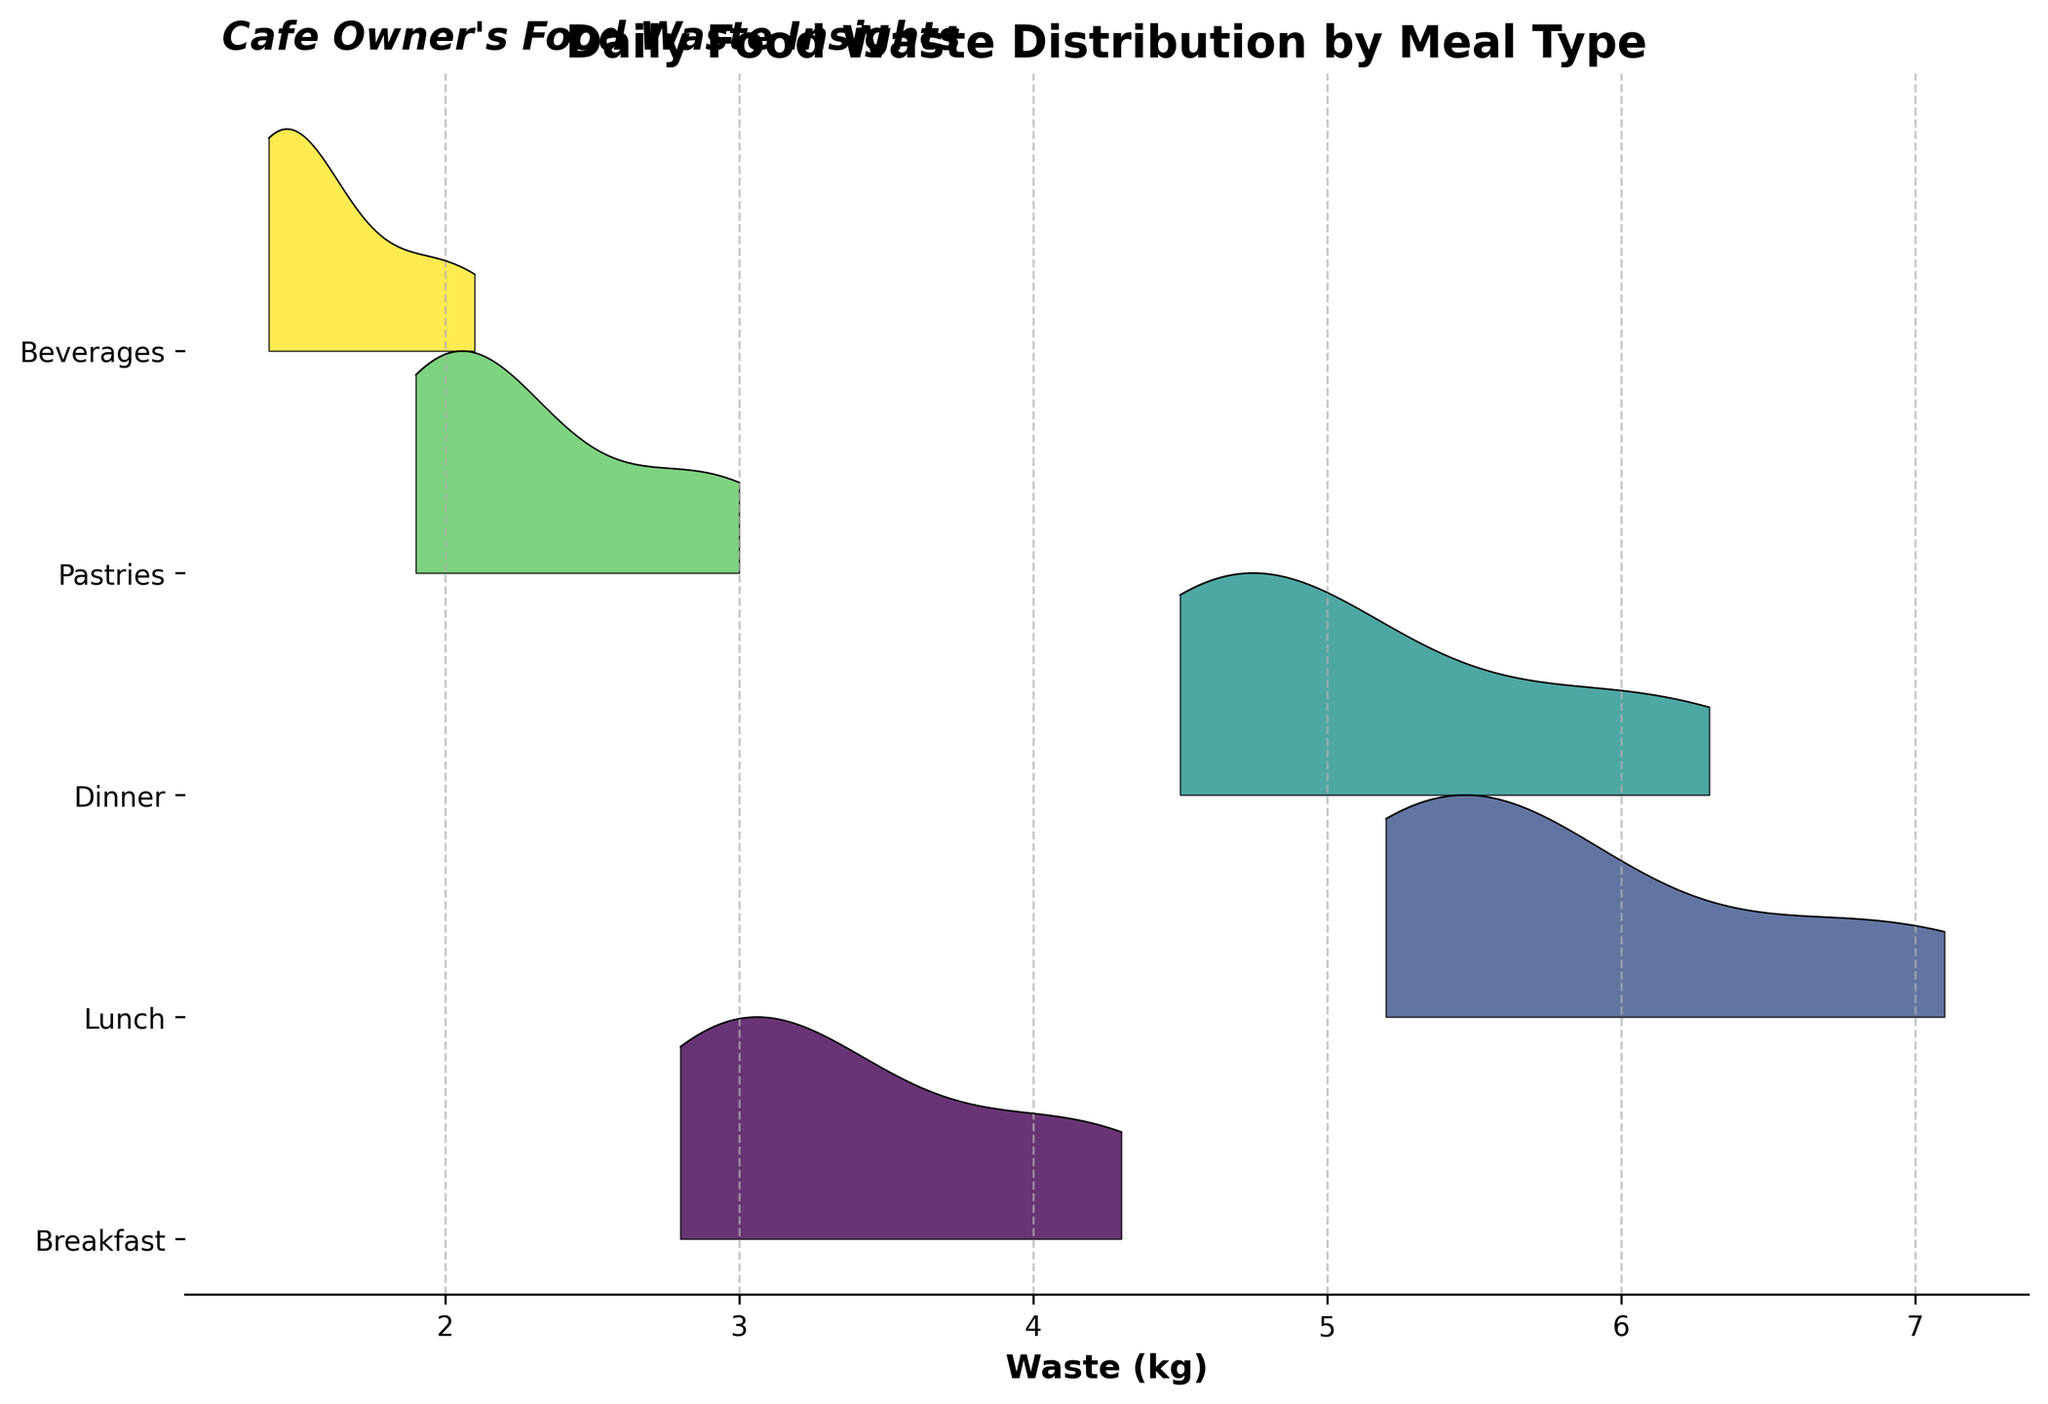What is the title of the plot? The title is usually at the top of the plot in a larger and bold font, making it easy to read. In this case, it reads "Daily Food Waste Distribution by Meal Type".
Answer: Daily Food Waste Distribution by Meal Type Which meal type has the widest spread of food waste distribution? By looking at the range of values on the x-axis for each meal type, Breakfast has the widest spread from approximately 2.8 kg to 4.3 kg.
Answer: Breakfast On which day does Lunch have the highest food waste? By examining the ridgeline plot for Lunch, the peak for Sunday is the highest compared to the other days.
Answer: Sunday What is the average food waste for Dinner over the week? List all food waste values for Dinner (4.8, 4.5, 4.7, 4.6, 5.2, 5.9, 6.3) and calculate the average: (4.8 + 4.5 + 4.7 + 4.6 + 5.2 + 5.9 + 6.3) / 7 = 5.14 kg.
Answer: 5.14 kg Which meal type consistently has the lowest food waste throughout the week? Beverages have the lowest waste values ranging roughly between 1.4 kg to 2.1 kg, less than any other meal type.
Answer: Beverages How does the total food waste for Pastries compare to that for Beverages over the week? Sum the food waste for Pastries (2.1, 1.9, 2.0, 2.0, 2.3, 2.8, 3.0) = 16.1 kg and Beverages (1.5, 1.4, 1.4, 1.4, 1.6, 1.9, 2.1) = 11.3 kg, and compare: 16.1 kg > 11.3 kg.
Answer: Pastries > Beverages Which meal type shows the highest variability in food waste? Observe the heights and variations in the ridgeline plot. Breakfast shows high variability with significant fluctuations between the lowest and highest values.
Answer: Breakfast What is the food waste peak value for Beverages? The peak value for the Beverages ridgeline is seen on Sunday at 2.1 kg.
Answer: 2.1 kg Which meal type shows an increasing trend in food waste from Monday to Sunday? By examining the ridgeline patterns, all meal types except Breakfast show an increasing trend from Monday to Sunday. However, Dinner has a more noticeable increasing trend.
Answer: Dinner On which day do all meal types have relatively higher food waste? Seeing that most peaks are the highest or relatively high on Sunday indicates that this particular day has generally higher food waste across all meal types.
Answer: Sunday 